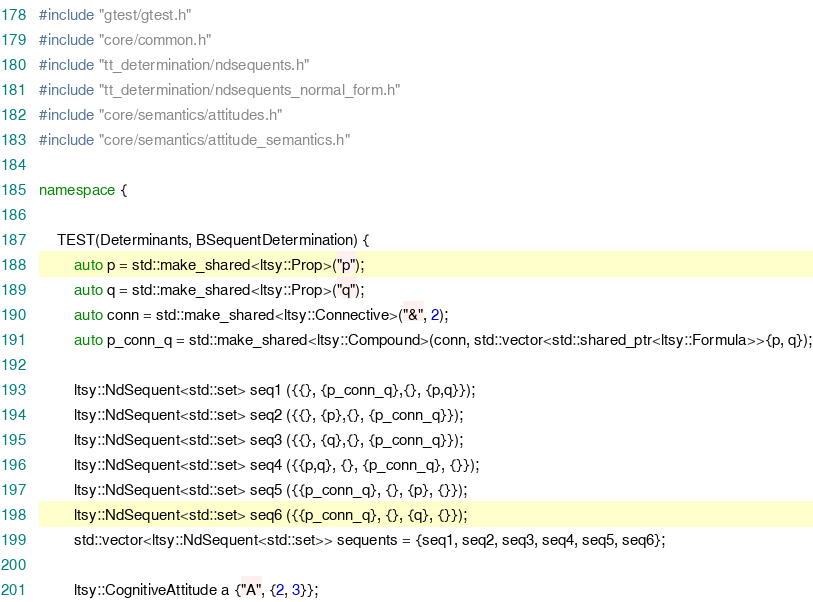Convert code to text. <code><loc_0><loc_0><loc_500><loc_500><_C++_>#include "gtest/gtest.h"
#include "core/common.h"
#include "tt_determination/ndsequents.h"
#include "tt_determination/ndsequents_normal_form.h"
#include "core/semantics/attitudes.h"
#include "core/semantics/attitude_semantics.h"

namespace {

    TEST(Determinants, BSequentDetermination) {
        auto p = std::make_shared<ltsy::Prop>("p");
        auto q = std::make_shared<ltsy::Prop>("q");
        auto conn = std::make_shared<ltsy::Connective>("&", 2);
        auto p_conn_q = std::make_shared<ltsy::Compound>(conn, std::vector<std::shared_ptr<ltsy::Formula>>{p, q});

        ltsy::NdSequent<std::set> seq1 ({{}, {p_conn_q},{}, {p,q}});
        ltsy::NdSequent<std::set> seq2 ({{}, {p},{}, {p_conn_q}});
        ltsy::NdSequent<std::set> seq3 ({{}, {q},{}, {p_conn_q}});
        ltsy::NdSequent<std::set> seq4 ({{p,q}, {}, {p_conn_q}, {}});
        ltsy::NdSequent<std::set> seq5 ({{p_conn_q}, {}, {p}, {}});
        ltsy::NdSequent<std::set> seq6 ({{p_conn_q}, {}, {q}, {}});
        std::vector<ltsy::NdSequent<std::set>> sequents = {seq1, seq2, seq3, seq4, seq5, seq6};

        ltsy::CognitiveAttitude a {"A", {2, 3}};</code> 